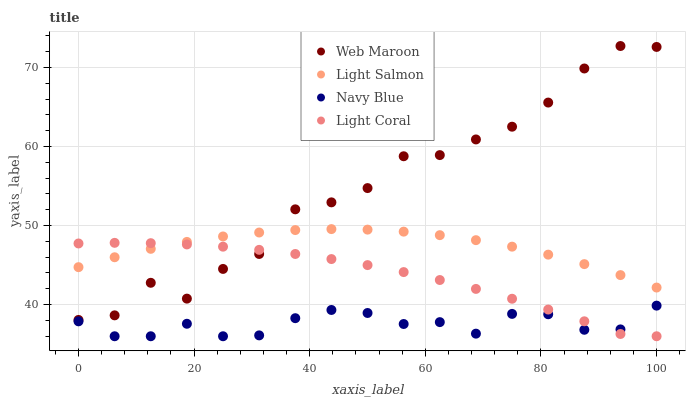Does Navy Blue have the minimum area under the curve?
Answer yes or no. Yes. Does Web Maroon have the maximum area under the curve?
Answer yes or no. Yes. Does Light Salmon have the minimum area under the curve?
Answer yes or no. No. Does Light Salmon have the maximum area under the curve?
Answer yes or no. No. Is Light Salmon the smoothest?
Answer yes or no. Yes. Is Web Maroon the roughest?
Answer yes or no. Yes. Is Navy Blue the smoothest?
Answer yes or no. No. Is Navy Blue the roughest?
Answer yes or no. No. Does Light Coral have the lowest value?
Answer yes or no. Yes. Does Light Salmon have the lowest value?
Answer yes or no. No. Does Web Maroon have the highest value?
Answer yes or no. Yes. Does Light Salmon have the highest value?
Answer yes or no. No. Is Navy Blue less than Light Salmon?
Answer yes or no. Yes. Is Light Salmon greater than Navy Blue?
Answer yes or no. Yes. Does Web Maroon intersect Light Coral?
Answer yes or no. Yes. Is Web Maroon less than Light Coral?
Answer yes or no. No. Is Web Maroon greater than Light Coral?
Answer yes or no. No. Does Navy Blue intersect Light Salmon?
Answer yes or no. No. 